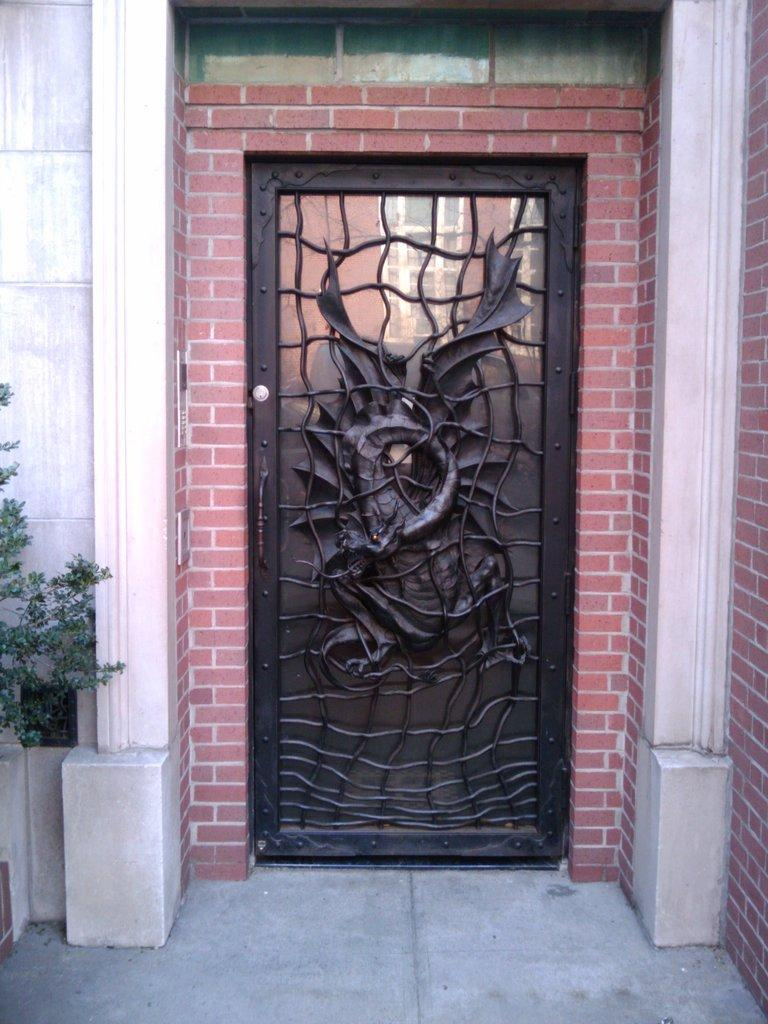What is the color of the door in the image? The door in the image is black. What other architectural feature can be seen in the image? There is a pillar in the image. What type of vegetation is present in the image? There is a green color plant on the left side of the image. What type of dress is the letter wearing in the image? There is no dress or letter present in the image. 